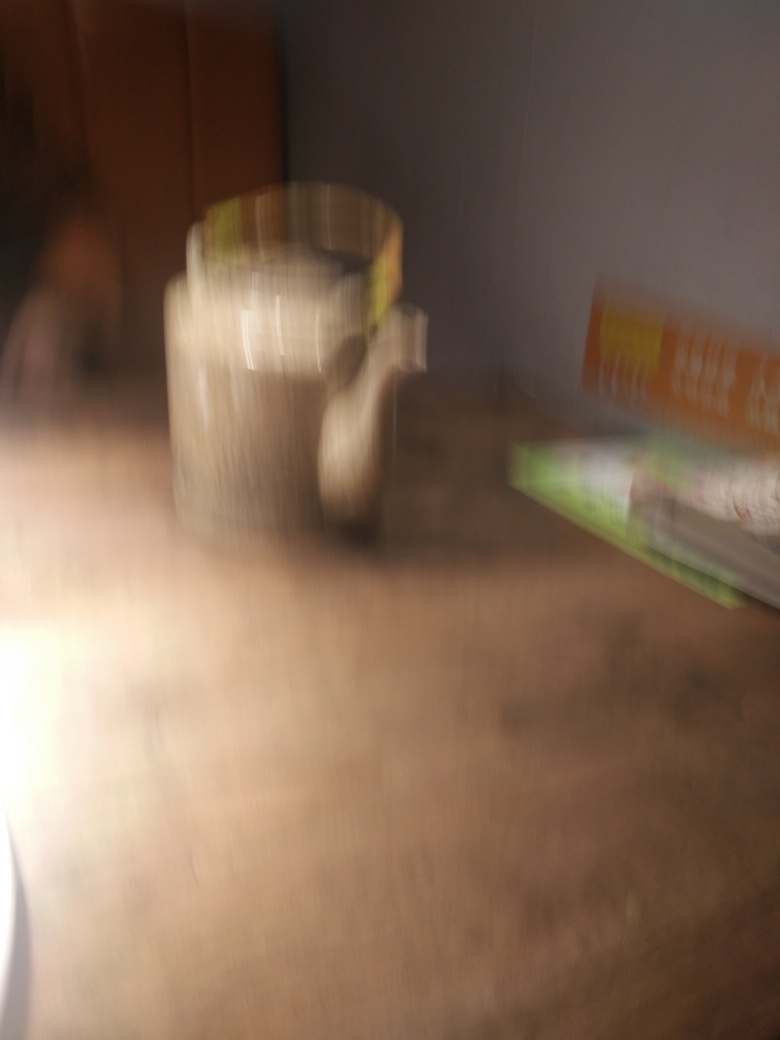Could the blurriness of the image affect the mood or atmosphere it conveys? Absolutely. The blurriness of an image can lend it a certain ethereal or dreamlike quality that can evoke feelings of nostalgia, mystery, or even confusion. It often encourages viewers to focus on the overall impression of the scene rather than the specific details, potentially leading to a more emotional or subjective response. 